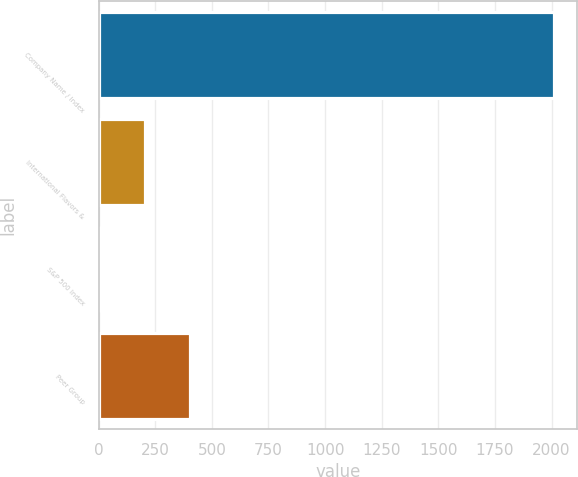<chart> <loc_0><loc_0><loc_500><loc_500><bar_chart><fcel>Company Name / Index<fcel>International Flavors &<fcel>S&P 500 Index<fcel>Peer Group<nl><fcel>2011<fcel>203<fcel>2.11<fcel>403.89<nl></chart> 